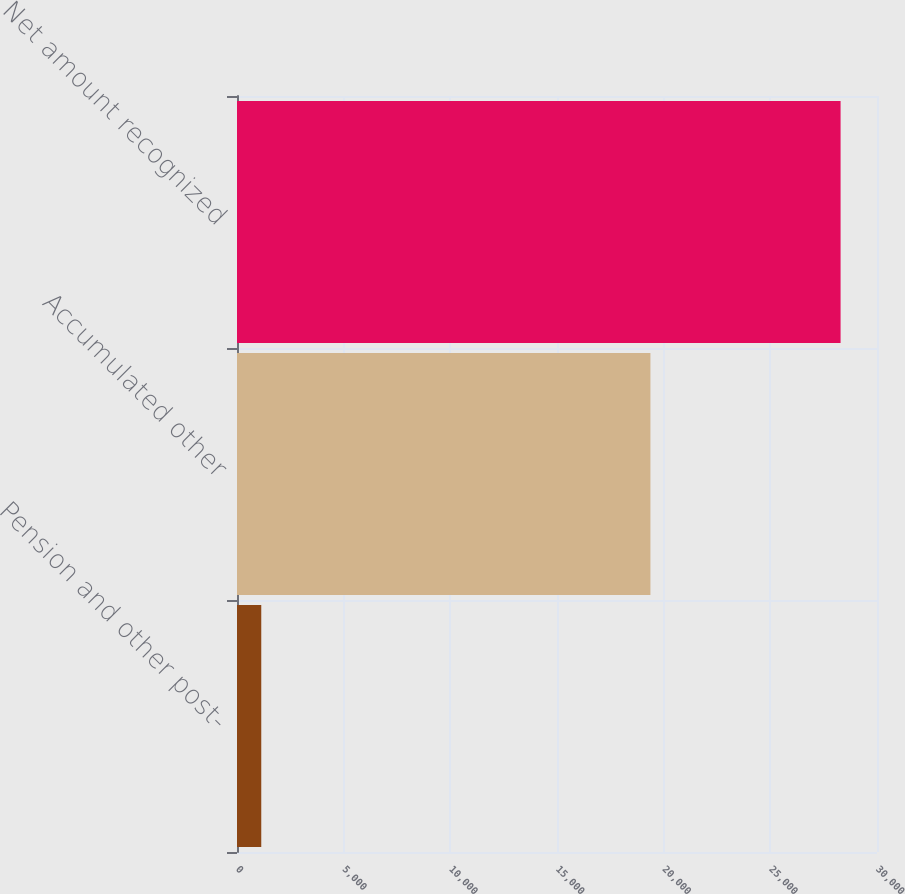Convert chart. <chart><loc_0><loc_0><loc_500><loc_500><bar_chart><fcel>Pension and other post-<fcel>Accumulated other<fcel>Net amount recognized<nl><fcel>1137<fcel>19379<fcel>28293<nl></chart> 